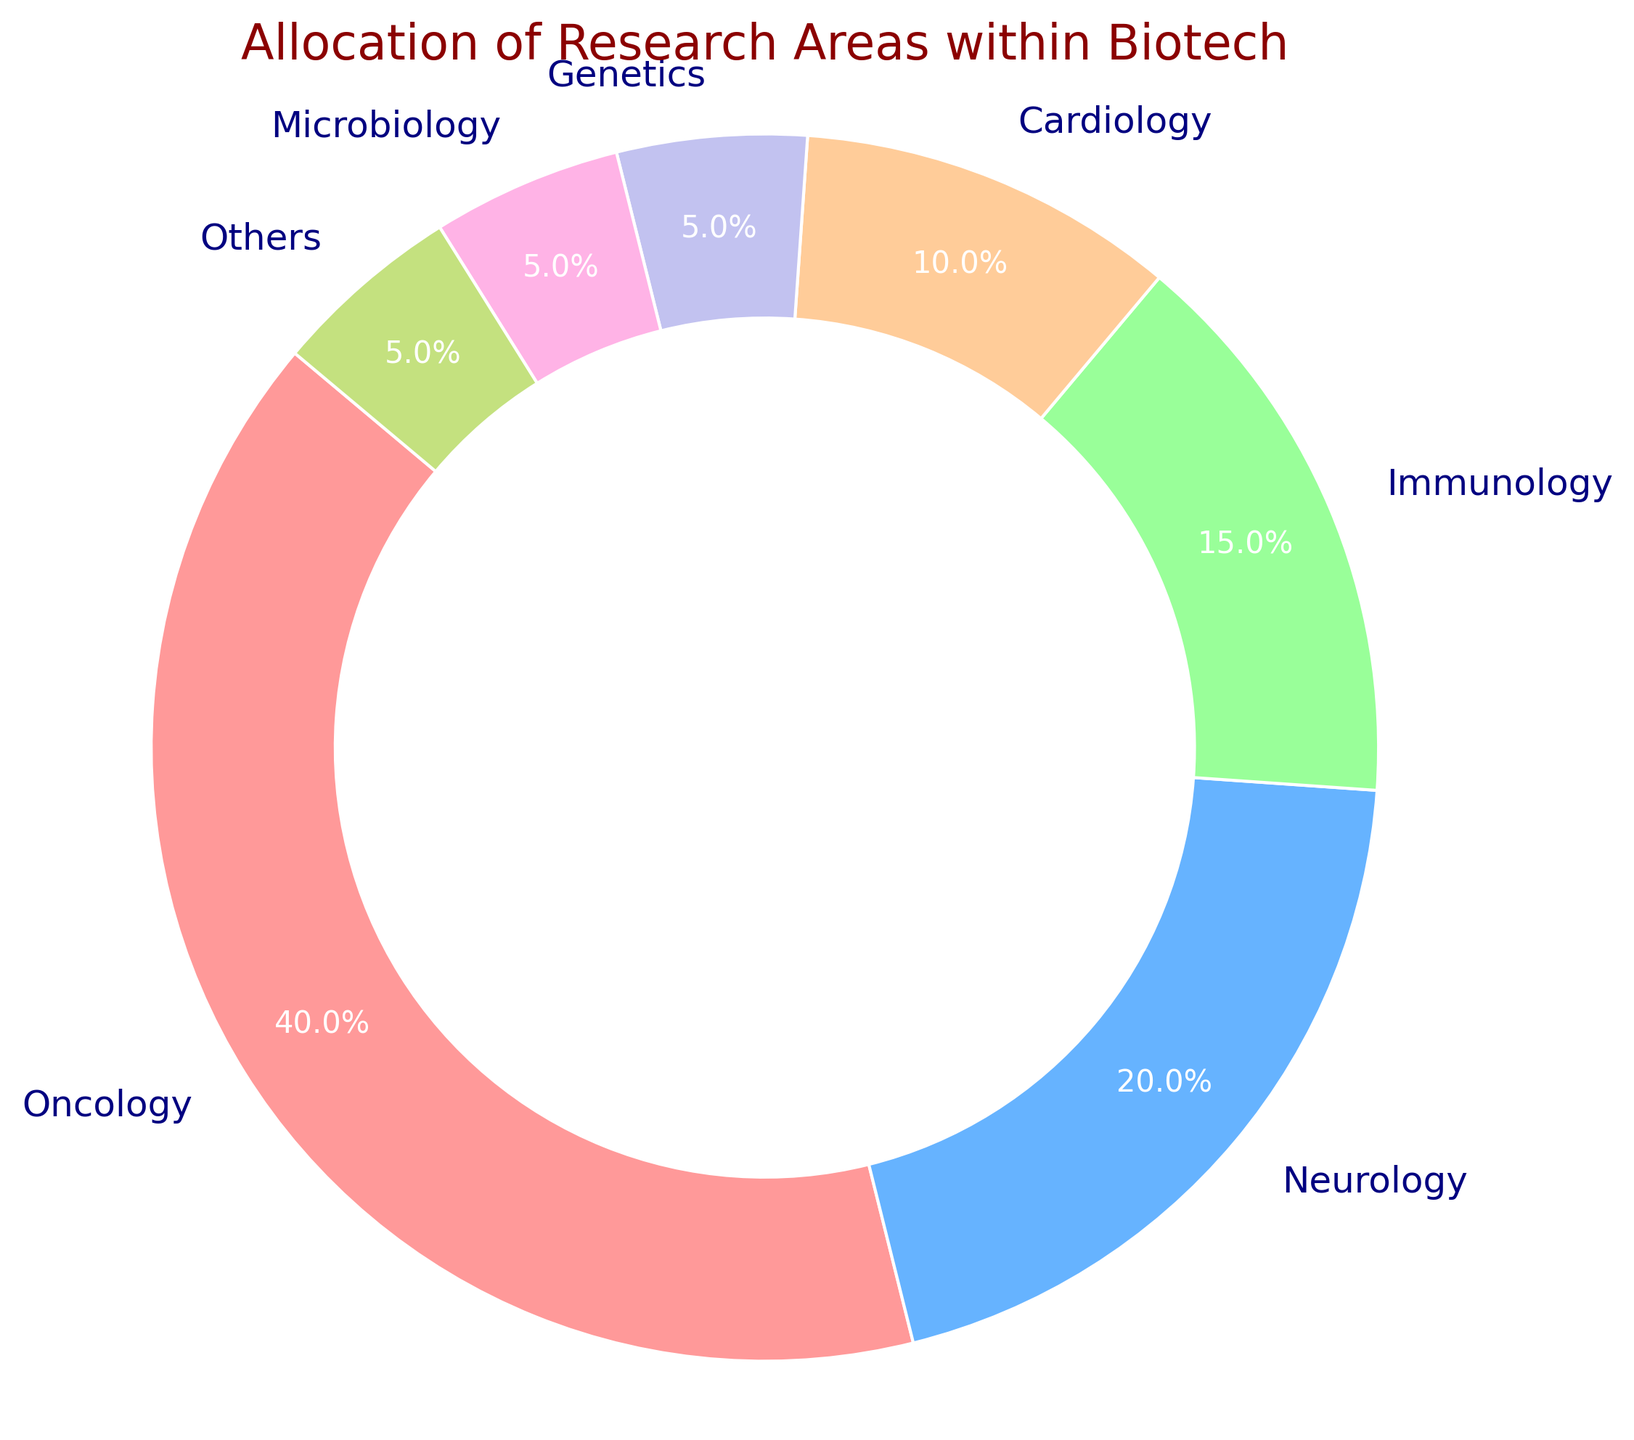What percentage of the biotech research is dedicated to Oncology? The slice labeled "Oncology" shows the percentage.
Answer: 40% Which category receives the least attention in biotech research? Identify the smallest wedge or the categories with the lowest percentages shown on the chart.
Answer: Genetics, Microbiology, and Others How much more research effort is allocated to Neurology compared to Immunology? Find the percentages of both Neurology and Immunology and then subtract the smaller from the larger (20% - 15%).
Answer: 5% What is the combined percentage of research allocated to Cardiology, Genetics, and Microbiology? Add the percentages of these three categories: 10% (Cardiology) + 5% (Genetics) + 5% (Microbiology).
Answer: 20% Which category's research allocation is closest to half that of Oncology's share? Compare percentages to see which one is around half of Oncology's 40% (40% / 2 = 20%).
Answer: Neurology If the research budget for Genetics were doubled, what would its new percentage be assuming no other changes? Double Genetics' percentage: 5% * 2 = 10%. Add 5% and subtract the same from 'Others' to maintain the total at 100%. Adjust 'Others’ percentage (5% - 5% = 0%).
Answer: 10% Rank the categories from highest to lowest based on their percentage allocation. List the categories in descending order of their percentages: 40% (Oncology), 20% (Neurology), 15% (Immunology), 10% (Cardiology), 5% (Genetics), 5% (Microbiology), 5% (Others).
Answer: Oncology, Neurology, Immunology, Cardiology, Genetics, Microbiology, Others What is the visual representation used to emphasize the inner part of the pie chart, making it appear as a ring chart? Look at the visual design of the chart which includes a circle in the center to create the ring effect.
Answer: Center circle 